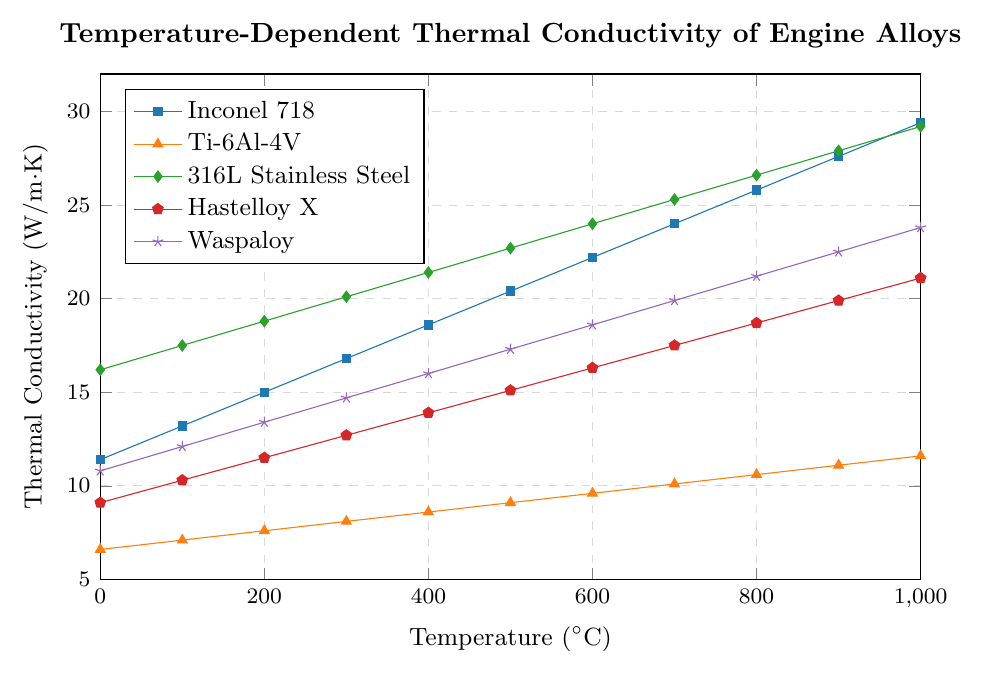Which alloy has the highest thermal conductivity at 1000°C? Locate the point at 1000°C on the x-axis for each alloy. The highest y-value corresponds to 316L Stainless Steel with a thermal conductivity of 29.2 W/m·K.
Answer: 316L Stainless Steel How much does the thermal conductivity of Inconel 718 increase from 0°C to 1000°C? Find the thermal conductivity of Inconel 718 at 0°C (11.4 W/m·K) and 1000°C (29.4 W/m·K), and compute the difference: 29.4 - 11.4 = 18.0 W/m·K.
Answer: 18.0 W/m·K Which alloy shows the smallest increase in thermal conductivity over the entire temperature range? Calculate the difference in thermal conductivity for each alloy from 0°C to 1000°C. Ti-6Al-4V has the smallest increase (11.6 - 6.6 = 5.0 W/m·K).
Answer: Ti-6Al-4V At 400°C, how much larger is the thermal conductivity of Hastelloy X compared to Ti-6Al-4V? Find the thermal conductivities at 400°C for Hastelloy X (13.9 W/m·K) and Ti-6Al-4V (8.6 W/m·K), then compute the difference: 13.9 - 8.6 = 5.3 W/m·K.
Answer: 5.3 W/m·K For which temperature range does Inconel 718 have a higher thermal conductivity than 316L Stainless Steel? Compare Inconel 718 and 316L Stainless Steel at each temperature. From 0°C to 200°C, 316L Stainless Steel has a higher thermal conductivity, whereas from 300°C to 1000°C, Inconel 718 surpasses it.
Answer: 300°C to 1000°C Is the rate of increase in thermal conductivity constant for any of the alloys? By visual inspection, check if the curves of any alloys are linear across the temperature range. No alloy has a perfectly linear increase, indicating varying rates of increase.
Answer: No What is the average thermal conductivity of Waspaloy at 0°C, 500°C, and 1000°C? Add the thermal conductivities of Waspaloy at these temperatures (10.8, 17.3, 23.8), then divide by 3: (10.8 + 17.3 + 23.8)/3 ≈ 17.3 W/m·K.
Answer: 17.3 W/m·K At 700°C, which alloy has the closest thermal conductivity value to Hastelloy X? Compare the thermal conductivities of all alloys at 700°C and find which is closest to Hastelloy X (17.5 W/m·K). Both Hastelloy X and Waspaloy are roughly equal at 700°C.
Answer: Waspaloy What is the total increase in thermal conductivity from 0°C to 1000°C across all five alloys? Calculate the increase for each alloy and sum them: (29.4-11.4) + (11.6-6.6) + (29.2-16.2) + (21.1-9.1) + (23.8-10.8) = 18 + 5 + 13 + 12 + 13 = 61 W/m·K.
Answer: 61 W/m·K How does the thermal conductivity of 316L Stainless Steel change between 600°C and 800°C? Determine the values at 600°C (24.0 W/m·K) and 800°C (26.6 W/m·K), then compute the difference: 26.6 - 24.0 = 2.6 W/m·K.
Answer: 2.6 W/m·K 